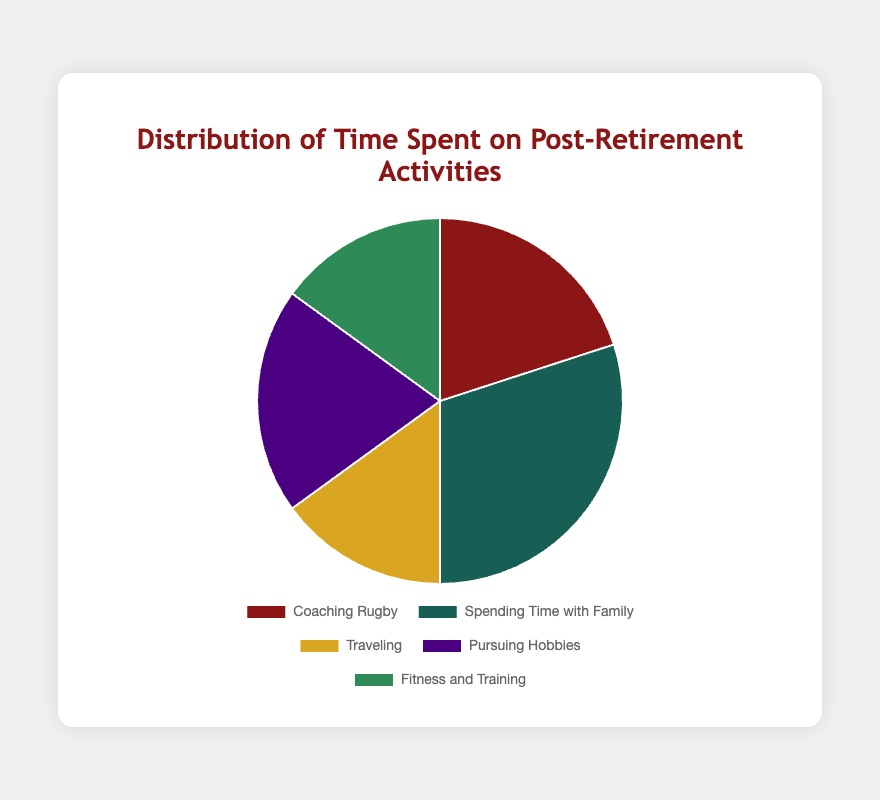What's the largest category in terms of percentage on the pie chart? The largest segment in the pie chart represents the category with the greatest proportion of the total pie. By examining the chart, we can see that "Spending Time with Family" has the largest slice.
Answer: Spending Time with Family Which two activities have the smallest percentages and what are they? We identify the two smallest slices on the pie chart, which represent the least percentages. The smallest segments are "Traveling" and "Fitness and Training," each with 15%.
Answer: Traveling and Fitness and Training What's the total percentage spent on activities related to physical exertion (Coaching Rugby and Fitness and Training)? To find the sum of the percentages for activities related to physical exertion, we add the percentages for "Coaching Rugby" (20%) and "Fitness and Training" (15%): 20 + 15 = 35%.
Answer: 35% How much more time is spent on "Spending Time with Family" compared to "Traveling"? We need to calculate the difference in percentages between "Spending Time with Family" (30%) and "Traveling" (15%): 30 - 15 = 15%.
Answer: 15% Are there any activities spent an equal amount of time on? If yes, which ones? We compare the percentages of each activity to determine if any two categories have the same value. "Traveling" and "Fitness and Training" each have 15%, and "Coaching Rugby" and "Pursuing Hobbies" each have 20%.
Answer: Yes, Traveling and Fitness and Training, Coaching Rugby and Pursuing Hobbies What is the average percentage of time spent on "Traveling," "Pursuing Hobbies," and "Fitness and Training"? To find the average, we sum the percentages for the three activities and divide by the number of activities: (15 + 20 + 15) / 3 = 50 / 3 ≈ 16.67%.
Answer: ≈ 16.67% Which activity's slice is represented by the color green? By visually identifying green in the pie chart, it corresponds to the category "Spending Time with Family."
Answer: Spending Time with Family How much total time is spent on non-coaching activities (i.e., all activities except "Coaching Rugby")? We subtract the time spent on "Coaching Rugby" from the total 100%: 100 - 20 = 80%.
Answer: 80% What is the difference in time percentage between "Pursuing Hobbies" and "Spending Time with Family"? We calculate the difference between "Pursuing Hobbies" (20%) and "Spending Time with Family" (30%): 30 - 20 = 10%.
Answer: 10% If time spent on "Traveling" increased to 20%, how would that affect the total percentage of "Traveling" and "Pursuing Hobbies" combined? If "Traveling" increased to 20%, we sum the new values of "Traveling" (20%) and "Pursuing Hobbies" (20%): 20 + 20 = 40%.
Answer: 40% 